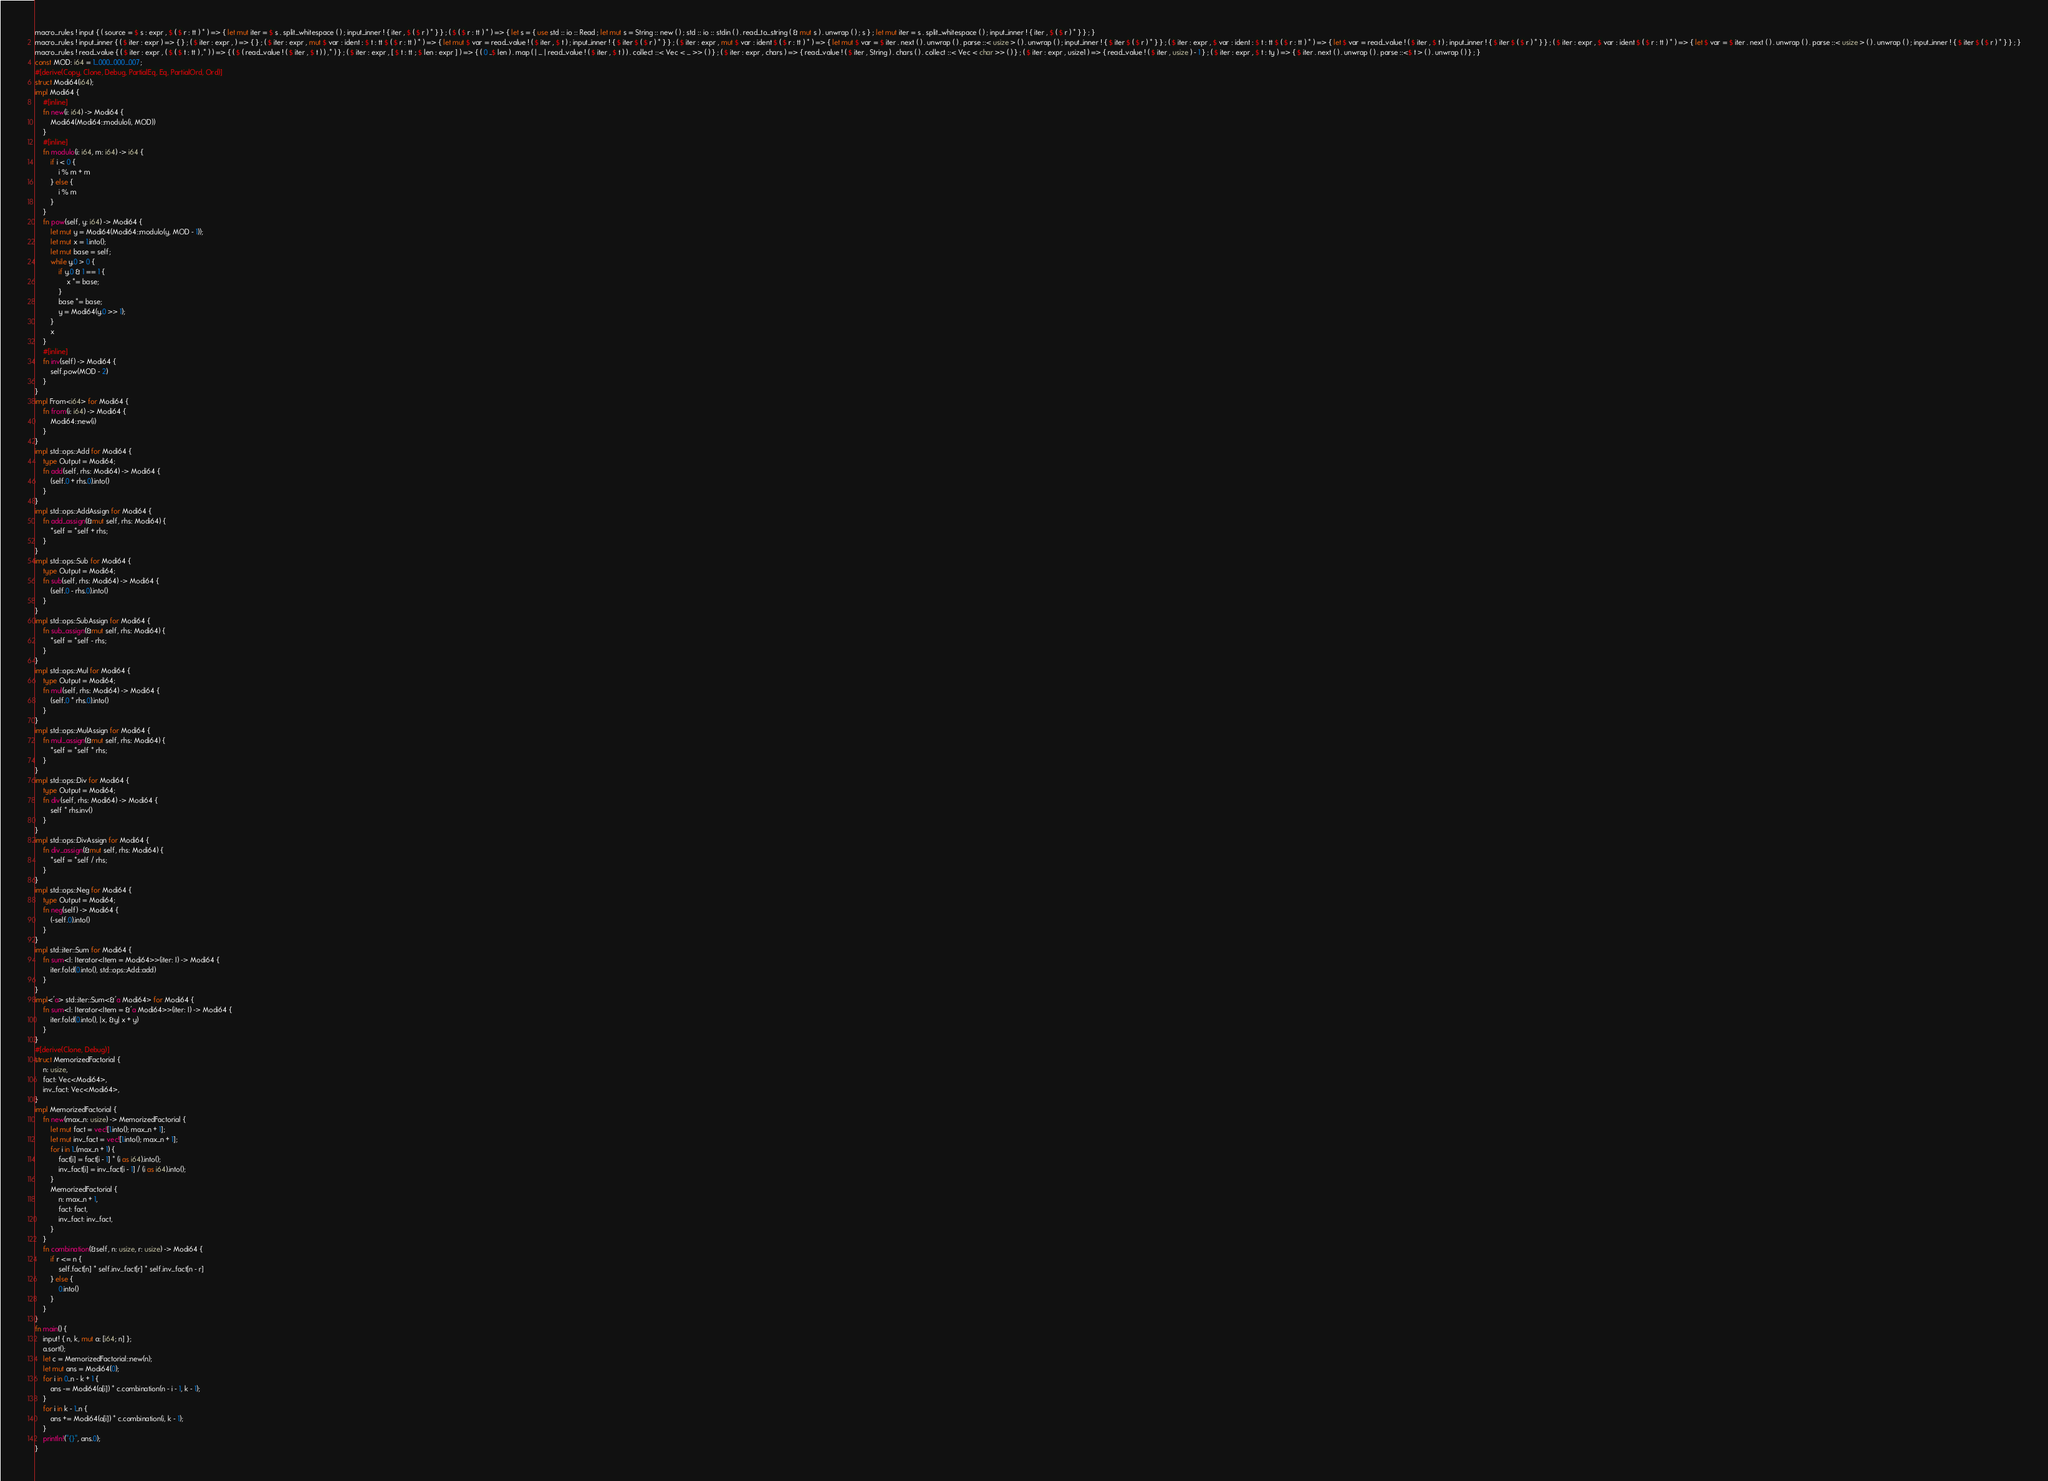Convert code to text. <code><loc_0><loc_0><loc_500><loc_500><_Rust_>macro_rules ! input { ( source = $ s : expr , $ ( $ r : tt ) * ) => { let mut iter = $ s . split_whitespace ( ) ; input_inner ! { iter , $ ( $ r ) * } } ; ( $ ( $ r : tt ) * ) => { let s = { use std :: io :: Read ; let mut s = String :: new ( ) ; std :: io :: stdin ( ) . read_to_string ( & mut s ) . unwrap ( ) ; s } ; let mut iter = s . split_whitespace ( ) ; input_inner ! { iter , $ ( $ r ) * } } ; }
macro_rules ! input_inner { ( $ iter : expr ) => { } ; ( $ iter : expr , ) => { } ; ( $ iter : expr , mut $ var : ident : $ t : tt $ ( $ r : tt ) * ) => { let mut $ var = read_value ! ( $ iter , $ t ) ; input_inner ! { $ iter $ ( $ r ) * } } ; ( $ iter : expr , mut $ var : ident $ ( $ r : tt ) * ) => { let mut $ var = $ iter . next ( ) . unwrap ( ) . parse ::< usize > ( ) . unwrap ( ) ; input_inner ! { $ iter $ ( $ r ) * } } ; ( $ iter : expr , $ var : ident : $ t : tt $ ( $ r : tt ) * ) => { let $ var = read_value ! ( $ iter , $ t ) ; input_inner ! { $ iter $ ( $ r ) * } } ; ( $ iter : expr , $ var : ident $ ( $ r : tt ) * ) => { let $ var = $ iter . next ( ) . unwrap ( ) . parse ::< usize > ( ) . unwrap ( ) ; input_inner ! { $ iter $ ( $ r ) * } } ; }
macro_rules ! read_value { ( $ iter : expr , ( $ ( $ t : tt ) ,* ) ) => { ( $ ( read_value ! ( $ iter , $ t ) ) ,* ) } ; ( $ iter : expr , [ $ t : tt ; $ len : expr ] ) => { ( 0 ..$ len ) . map ( | _ | read_value ! ( $ iter , $ t ) ) . collect ::< Vec < _ >> ( ) } ; ( $ iter : expr , chars ) => { read_value ! ( $ iter , String ) . chars ( ) . collect ::< Vec < char >> ( ) } ; ( $ iter : expr , usize1 ) => { read_value ! ( $ iter , usize ) - 1 } ; ( $ iter : expr , $ t : ty ) => { $ iter . next ( ) . unwrap ( ) . parse ::<$ t > ( ) . unwrap ( ) } ; }
const MOD: i64 = 1_000_000_007;
#[derive(Copy, Clone, Debug, PartialEq, Eq, PartialOrd, Ord)]
struct Modi64(i64);
impl Modi64 {
    #[inline]
    fn new(i: i64) -> Modi64 {
        Modi64(Modi64::modulo(i, MOD))
    }
    #[inline]
    fn modulo(i: i64, m: i64) -> i64 {
        if i < 0 {
            i % m + m
        } else {
            i % m
        }
    }
    fn pow(self, y: i64) -> Modi64 {
        let mut y = Modi64(Modi64::modulo(y, MOD - 1));
        let mut x = 1.into();
        let mut base = self;
        while y.0 > 0 {
            if y.0 & 1 == 1 {
                x *= base;
            }
            base *= base;
            y = Modi64(y.0 >> 1);
        }
        x
    }
    #[inline]
    fn inv(self) -> Modi64 {
        self.pow(MOD - 2)
    }
}
impl From<i64> for Modi64 {
    fn from(i: i64) -> Modi64 {
        Modi64::new(i)
    }
}
impl std::ops::Add for Modi64 {
    type Output = Modi64;
    fn add(self, rhs: Modi64) -> Modi64 {
        (self.0 + rhs.0).into()
    }
}
impl std::ops::AddAssign for Modi64 {
    fn add_assign(&mut self, rhs: Modi64) {
        *self = *self + rhs;
    }
}
impl std::ops::Sub for Modi64 {
    type Output = Modi64;
    fn sub(self, rhs: Modi64) -> Modi64 {
        (self.0 - rhs.0).into()
    }
}
impl std::ops::SubAssign for Modi64 {
    fn sub_assign(&mut self, rhs: Modi64) {
        *self = *self - rhs;
    }
}
impl std::ops::Mul for Modi64 {
    type Output = Modi64;
    fn mul(self, rhs: Modi64) -> Modi64 {
        (self.0 * rhs.0).into()
    }
}
impl std::ops::MulAssign for Modi64 {
    fn mul_assign(&mut self, rhs: Modi64) {
        *self = *self * rhs;
    }
}
impl std::ops::Div for Modi64 {
    type Output = Modi64;
    fn div(self, rhs: Modi64) -> Modi64 {
        self * rhs.inv()
    }
}
impl std::ops::DivAssign for Modi64 {
    fn div_assign(&mut self, rhs: Modi64) {
        *self = *self / rhs;
    }
}
impl std::ops::Neg for Modi64 {
    type Output = Modi64;
    fn neg(self) -> Modi64 {
        (-self.0).into()
    }
}
impl std::iter::Sum for Modi64 {
    fn sum<I: Iterator<Item = Modi64>>(iter: I) -> Modi64 {
        iter.fold(0.into(), std::ops::Add::add)
    }
}
impl<'a> std::iter::Sum<&'a Modi64> for Modi64 {
    fn sum<I: Iterator<Item = &'a Modi64>>(iter: I) -> Modi64 {
        iter.fold(0.into(), |x, &y| x + y)
    }
}
#[derive(Clone, Debug)]
struct MemorizedFactorial {
    n: usize,
    fact: Vec<Modi64>,
    inv_fact: Vec<Modi64>,
}
impl MemorizedFactorial {
    fn new(max_n: usize) -> MemorizedFactorial {
        let mut fact = vec![1.into(); max_n + 1];
        let mut inv_fact = vec![1.into(); max_n + 1];
        for i in 1..(max_n + 1) {
            fact[i] = fact[i - 1] * (i as i64).into();
            inv_fact[i] = inv_fact[i - 1] / (i as i64).into();
        }
        MemorizedFactorial {
            n: max_n + 1,
            fact: fact,
            inv_fact: inv_fact,
        }
    }
    fn combination(&self, n: usize, r: usize) -> Modi64 {
        if r <= n {
            self.fact[n] * self.inv_fact[r] * self.inv_fact[n - r]
        } else {
            0.into()
        }
    }
}
fn main() {
    input! { n, k, mut a: [i64; n] };
    a.sort();
    let c = MemorizedFactorial::new(n);
    let mut ans = Modi64(0);
    for i in 0..n - k + 1 {
        ans -= Modi64(a[i]) * c.combination(n - i - 1, k - 1);
    }
    for i in k - 1..n {
        ans += Modi64(a[i]) * c.combination(i, k - 1);
    }
    println!("{}", ans.0);
}
</code> 